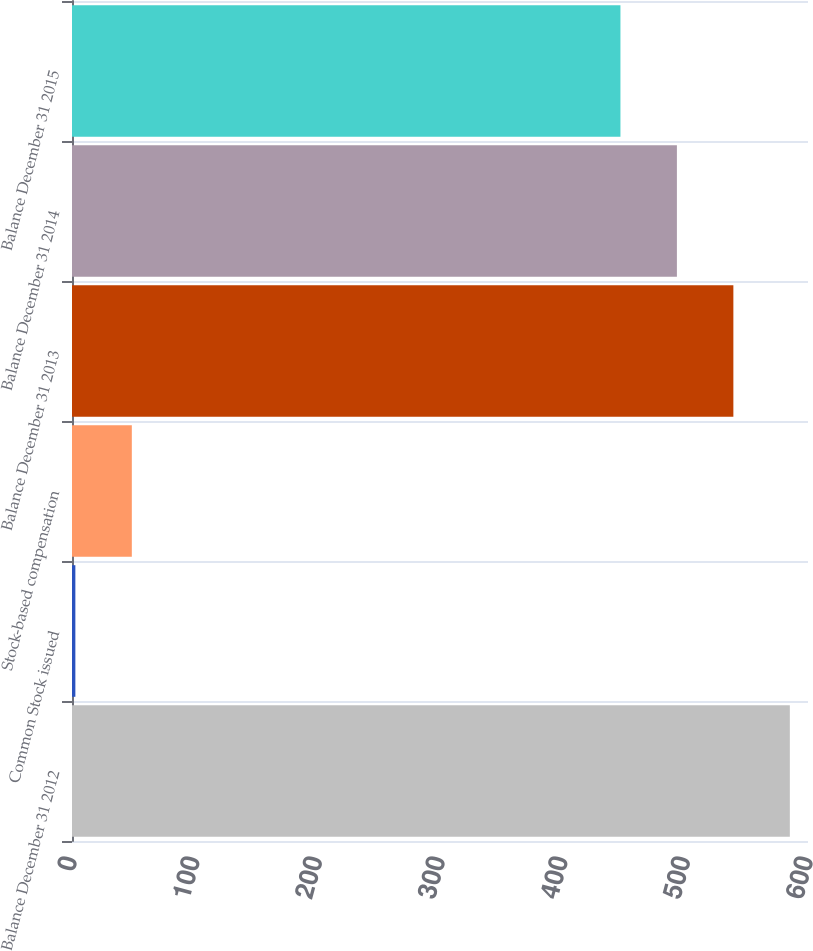Convert chart. <chart><loc_0><loc_0><loc_500><loc_500><bar_chart><fcel>Balance December 31 2012<fcel>Common Stock issued<fcel>Stock-based compensation<fcel>Balance December 31 2013<fcel>Balance December 31 2014<fcel>Balance December 31 2015<nl><fcel>585.19<fcel>2.74<fcel>48.77<fcel>539.16<fcel>493.13<fcel>447.1<nl></chart> 